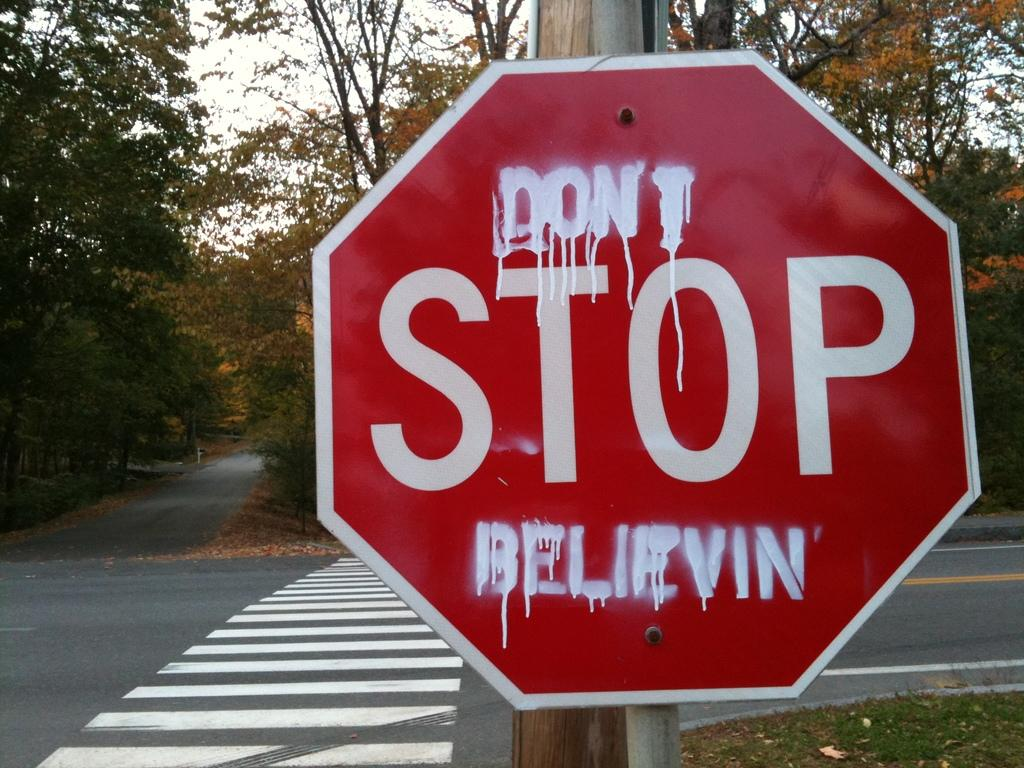Provide a one-sentence caption for the provided image. A sign with "Don't Stop Believing" written on it. 